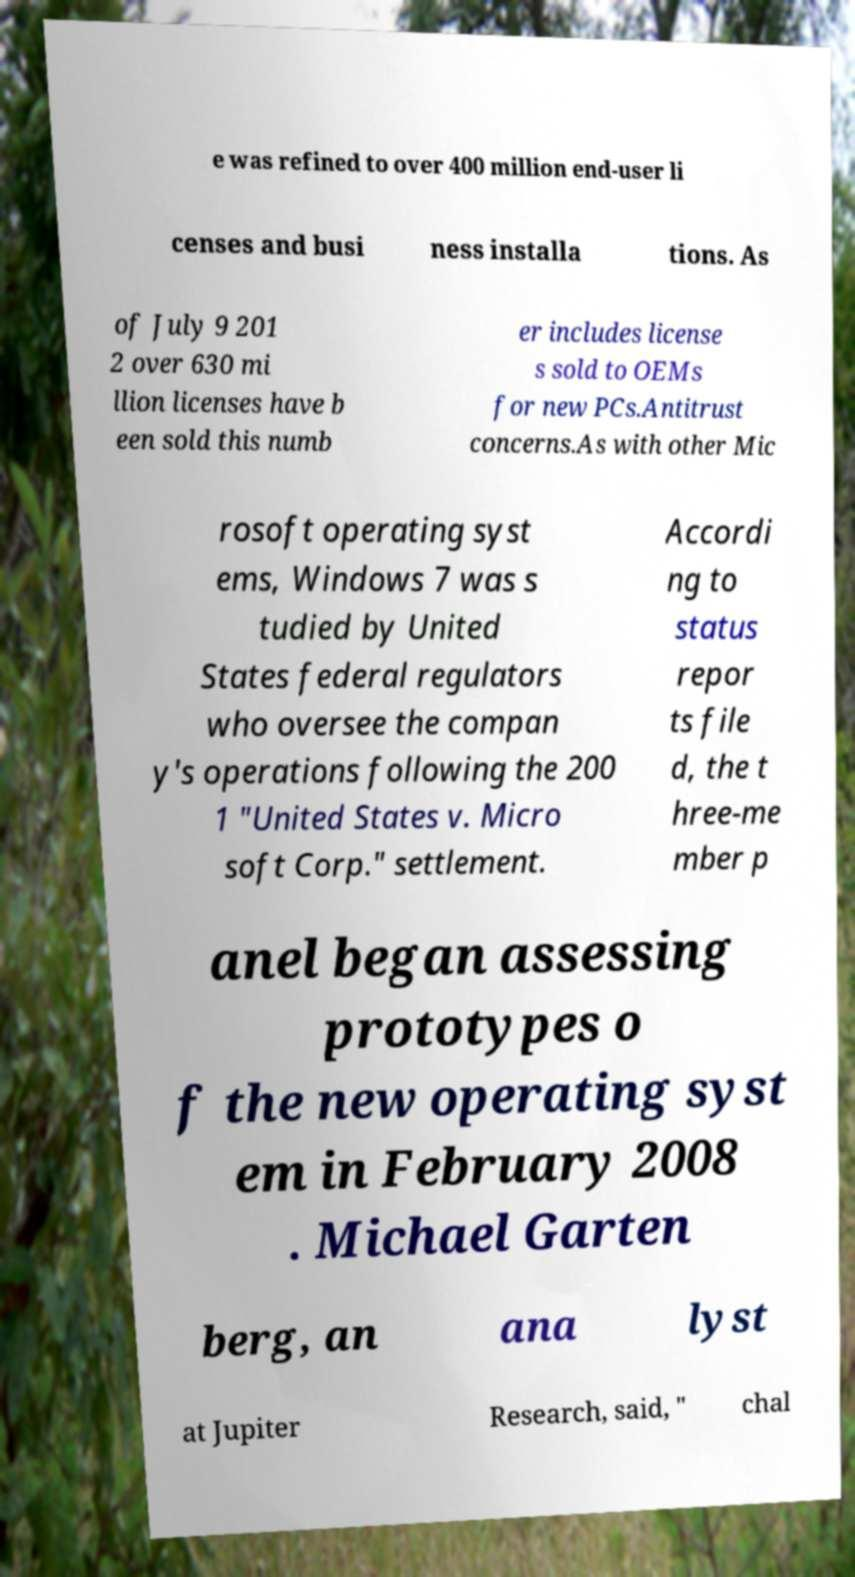Could you extract and type out the text from this image? e was refined to over 400 million end-user li censes and busi ness installa tions. As of July 9 201 2 over 630 mi llion licenses have b een sold this numb er includes license s sold to OEMs for new PCs.Antitrust concerns.As with other Mic rosoft operating syst ems, Windows 7 was s tudied by United States federal regulators who oversee the compan y's operations following the 200 1 "United States v. Micro soft Corp." settlement. Accordi ng to status repor ts file d, the t hree-me mber p anel began assessing prototypes o f the new operating syst em in February 2008 . Michael Garten berg, an ana lyst at Jupiter Research, said, " chal 